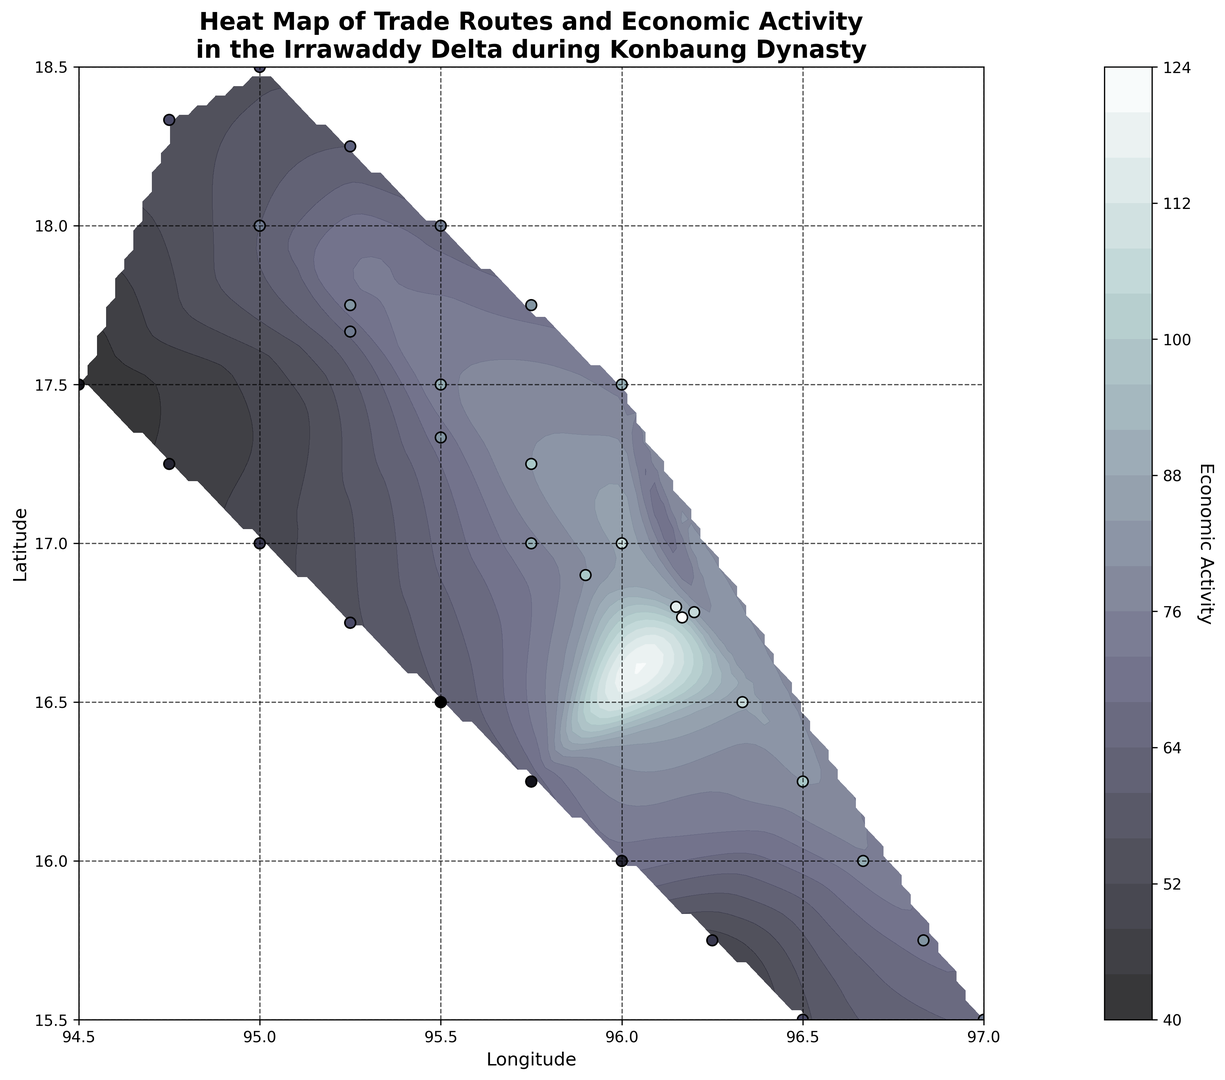How are the zones of highest economic activity represented on the map? The zones of highest economic activity are represented by the darkest shade in the contour plot and scattered points with the largest value (darkest shades) found in the most concentrated areas. These include central coordinates near (16.7667, 96.1667) and (16.8000, 96.1500).
Answer: By darkest shade Which section of the map shows the lowest economic activity? The lowest economic activity on the map is depicted by the lightest shades in the contour plot. This area is found in the south-western coordinate (17.5000, 94.5000).
Answer: South-western section with coordinates around (17.5000, 94.5000) Compare the economic activity between the northern and southern regions of the map. Overall, the northern region exhibits comparatively lower economic activity, with lighter contours, except around (18.0000, 95.0000). The southern region maintains higher economic activity with multiple dark contour areas especially around coordinates (16.5000, 96.3333) and (16.8000, 96.1500).
Answer: Southern region is higher on average What is the range of economic activity values shown in the heatmap? The heatmap uses contour shades to display economic activity, which ranges from the lightest shade indicating the lowest value (40s) to the darkest shade representing the highest value in the 95. The colorbar assists in this identification.
Answer: 40-95 Are there any observable patterns in economic activity related to latitude based on the map? Observing the latitude lines, higher economic activities are concentrated around 16.5000 up to 17.0000 latitudes, marked by darker shades, with a slight drop as we move northward and southward starting from lighter shades
Answer: High activity from latitudes 16.5000 to 17.0000 Which location has the maximum economic activity, and what is its economic activity value? By looking at the highest contour shade and overlaid scatter plot values, the location with maximum economic activity is near (16.7667, 96.1667), where the economic activity value is the highest recorded, which is 95.
Answer: (16.7667, 96.1667) with 95 How does the economic activity change as we move eastwards from longitude 95.0 to 97.0? As we move eastward from longitude 95.0 to 97.0, initially, there is an increase in economic activity, shown in scatter points and contour shades intensifying towards 96.0 and 96.1500, and then levels off with moderately high activity till the far east end.
Answer: Increases initially then stabilizes 